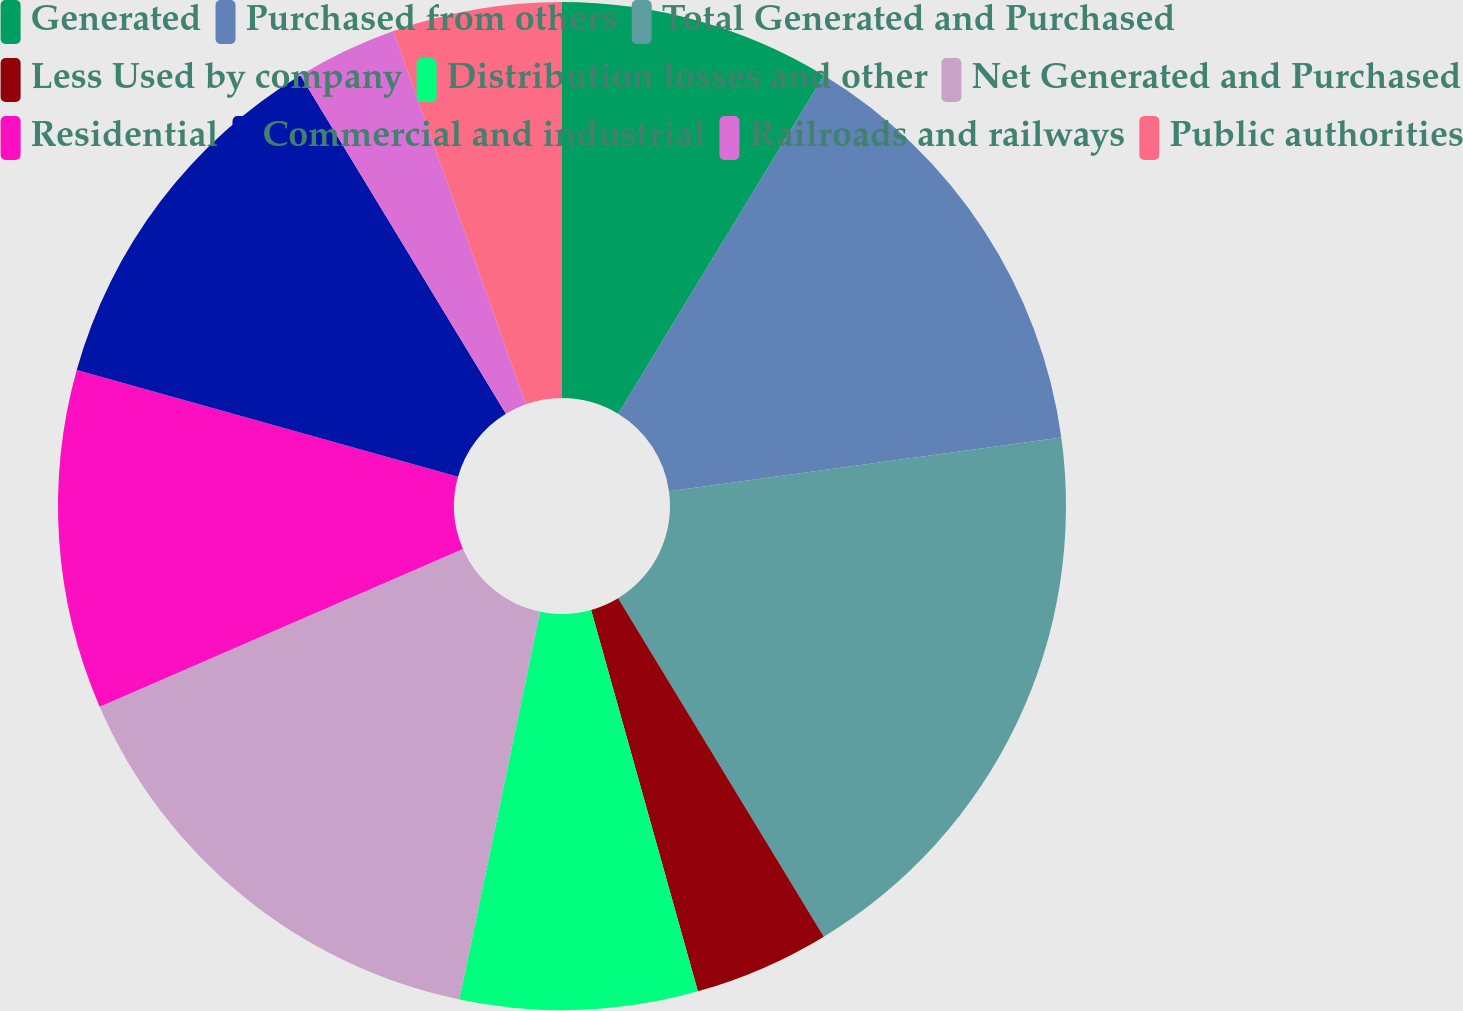Convert chart to OTSL. <chart><loc_0><loc_0><loc_500><loc_500><pie_chart><fcel>Generated<fcel>Purchased from others<fcel>Total Generated and Purchased<fcel>Less Used by company<fcel>Distribution losses and other<fcel>Net Generated and Purchased<fcel>Residential<fcel>Commercial and industrial<fcel>Railroads and railways<fcel>Public authorities<nl><fcel>8.7%<fcel>14.13%<fcel>18.48%<fcel>4.35%<fcel>7.61%<fcel>15.22%<fcel>10.87%<fcel>11.96%<fcel>3.26%<fcel>5.43%<nl></chart> 